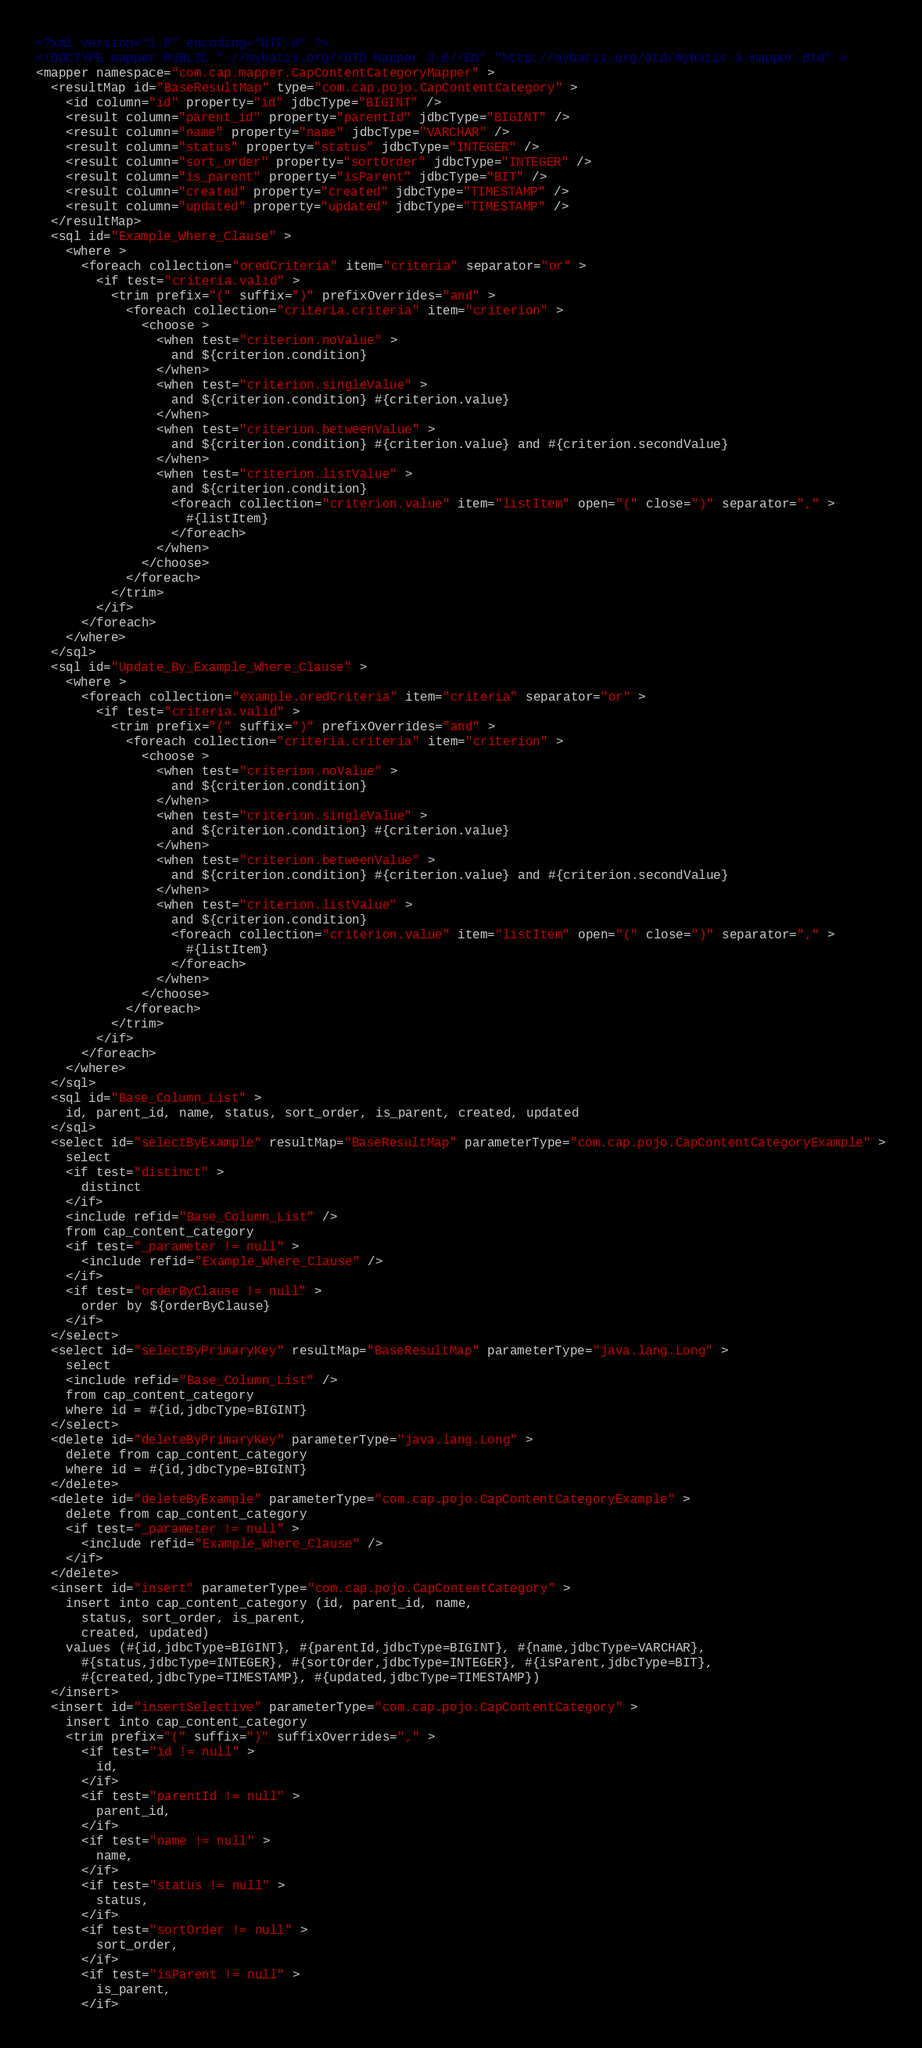Convert code to text. <code><loc_0><loc_0><loc_500><loc_500><_XML_><?xml version="1.0" encoding="UTF-8" ?>
<!DOCTYPE mapper PUBLIC "-//mybatis.org//DTD Mapper 3.0//EN" "http://mybatis.org/dtd/mybatis-3-mapper.dtd" >
<mapper namespace="com.cap.mapper.CapContentCategoryMapper" >
  <resultMap id="BaseResultMap" type="com.cap.pojo.CapContentCategory" >
    <id column="id" property="id" jdbcType="BIGINT" />
    <result column="parent_id" property="parentId" jdbcType="BIGINT" />
    <result column="name" property="name" jdbcType="VARCHAR" />
    <result column="status" property="status" jdbcType="INTEGER" />
    <result column="sort_order" property="sortOrder" jdbcType="INTEGER" />
    <result column="is_parent" property="isParent" jdbcType="BIT" />
    <result column="created" property="created" jdbcType="TIMESTAMP" />
    <result column="updated" property="updated" jdbcType="TIMESTAMP" />
  </resultMap>
  <sql id="Example_Where_Clause" >
    <where >
      <foreach collection="oredCriteria" item="criteria" separator="or" >
        <if test="criteria.valid" >
          <trim prefix="(" suffix=")" prefixOverrides="and" >
            <foreach collection="criteria.criteria" item="criterion" >
              <choose >
                <when test="criterion.noValue" >
                  and ${criterion.condition}
                </when>
                <when test="criterion.singleValue" >
                  and ${criterion.condition} #{criterion.value}
                </when>
                <when test="criterion.betweenValue" >
                  and ${criterion.condition} #{criterion.value} and #{criterion.secondValue}
                </when>
                <when test="criterion.listValue" >
                  and ${criterion.condition}
                  <foreach collection="criterion.value" item="listItem" open="(" close=")" separator="," >
                    #{listItem}
                  </foreach>
                </when>
              </choose>
            </foreach>
          </trim>
        </if>
      </foreach>
    </where>
  </sql>
  <sql id="Update_By_Example_Where_Clause" >
    <where >
      <foreach collection="example.oredCriteria" item="criteria" separator="or" >
        <if test="criteria.valid" >
          <trim prefix="(" suffix=")" prefixOverrides="and" >
            <foreach collection="criteria.criteria" item="criterion" >
              <choose >
                <when test="criterion.noValue" >
                  and ${criterion.condition}
                </when>
                <when test="criterion.singleValue" >
                  and ${criterion.condition} #{criterion.value}
                </when>
                <when test="criterion.betweenValue" >
                  and ${criterion.condition} #{criterion.value} and #{criterion.secondValue}
                </when>
                <when test="criterion.listValue" >
                  and ${criterion.condition}
                  <foreach collection="criterion.value" item="listItem" open="(" close=")" separator="," >
                    #{listItem}
                  </foreach>
                </when>
              </choose>
            </foreach>
          </trim>
        </if>
      </foreach>
    </where>
  </sql>
  <sql id="Base_Column_List" >
    id, parent_id, name, status, sort_order, is_parent, created, updated
  </sql>
  <select id="selectByExample" resultMap="BaseResultMap" parameterType="com.cap.pojo.CapContentCategoryExample" >
    select
    <if test="distinct" >
      distinct
    </if>
    <include refid="Base_Column_List" />
    from cap_content_category
    <if test="_parameter != null" >
      <include refid="Example_Where_Clause" />
    </if>
    <if test="orderByClause != null" >
      order by ${orderByClause}
    </if>
  </select>
  <select id="selectByPrimaryKey" resultMap="BaseResultMap" parameterType="java.lang.Long" >
    select 
    <include refid="Base_Column_List" />
    from cap_content_category
    where id = #{id,jdbcType=BIGINT}
  </select>
  <delete id="deleteByPrimaryKey" parameterType="java.lang.Long" >
    delete from cap_content_category
    where id = #{id,jdbcType=BIGINT}
  </delete>
  <delete id="deleteByExample" parameterType="com.cap.pojo.CapContentCategoryExample" >
    delete from cap_content_category
    <if test="_parameter != null" >
      <include refid="Example_Where_Clause" />
    </if>
  </delete>
  <insert id="insert" parameterType="com.cap.pojo.CapContentCategory" >
    insert into cap_content_category (id, parent_id, name, 
      status, sort_order, is_parent, 
      created, updated)
    values (#{id,jdbcType=BIGINT}, #{parentId,jdbcType=BIGINT}, #{name,jdbcType=VARCHAR}, 
      #{status,jdbcType=INTEGER}, #{sortOrder,jdbcType=INTEGER}, #{isParent,jdbcType=BIT}, 
      #{created,jdbcType=TIMESTAMP}, #{updated,jdbcType=TIMESTAMP})
  </insert>
  <insert id="insertSelective" parameterType="com.cap.pojo.CapContentCategory" >
    insert into cap_content_category
    <trim prefix="(" suffix=")" suffixOverrides="," >
      <if test="id != null" >
        id,
      </if>
      <if test="parentId != null" >
        parent_id,
      </if>
      <if test="name != null" >
        name,
      </if>
      <if test="status != null" >
        status,
      </if>
      <if test="sortOrder != null" >
        sort_order,
      </if>
      <if test="isParent != null" >
        is_parent,
      </if></code> 